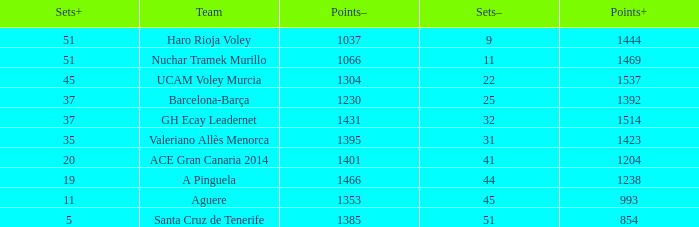Who is the team who had a Sets+ number smaller than 20, a Sets- number of 45, and a Points+ number smaller than 1238? Aguere. 